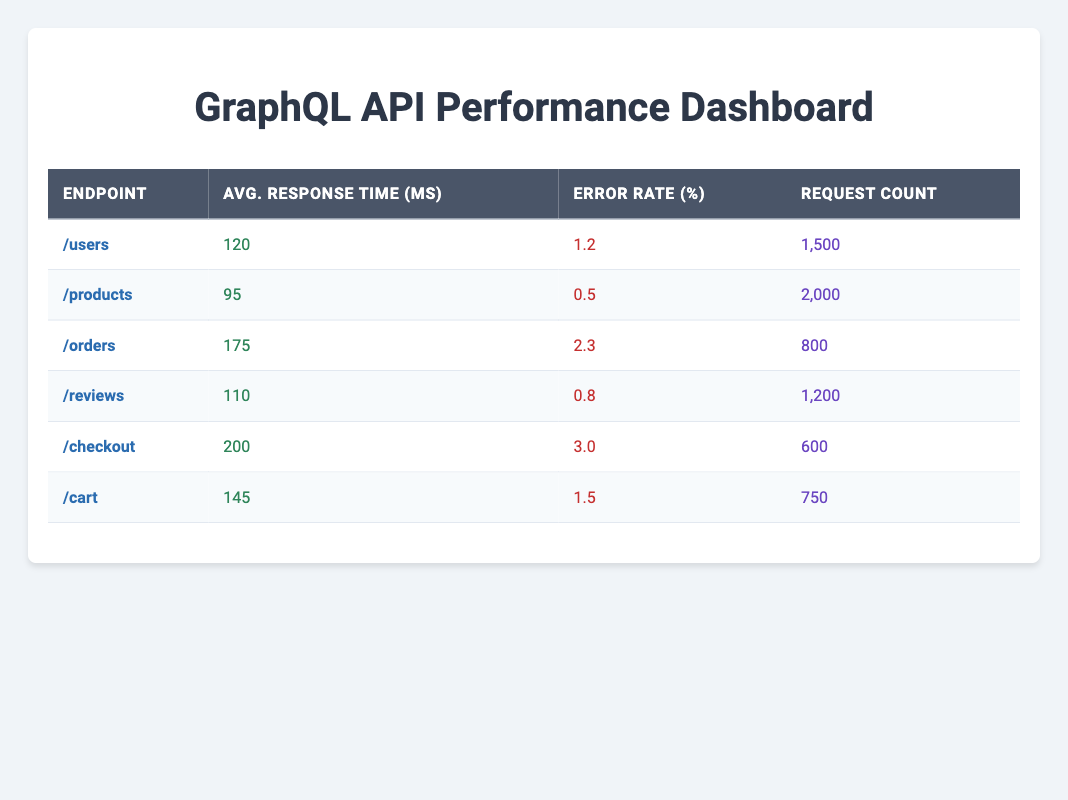What is the average response time for the /products endpoint? The average response time for the /products endpoint is directly provided in the table, which shows the value as 95 milliseconds.
Answer: 95 ms Which endpoint has the highest error rate? To determine which endpoint has the highest error rate, we look through the error rate percentages in the table. The /checkout endpoint has the highest value at 3.0%.
Answer: /checkout Calculate the average response time of all endpoints. First, we sum the average response times: 120 + 95 + 175 + 110 + 200 + 145 = 945 ms. Since there are 6 endpoints, we divide: 945 / 6 = 157.5 ms.
Answer: 157.5 ms Is the error rate for /reviews lower than 1%? In the table, the error rate for /reviews is listed as 0.8%, which is indeed lower than 1%.
Answer: Yes Which endpoint has a request count of 800? The request count for each endpoint is listed in the table. The /orders endpoint has a request count of 800.
Answer: /orders What is the sum of the request counts for endpoints with an error rate below 2%? The endpoints with error rates below 2% are /users (1500), /products (2000), and /reviews (1200). Adding these request counts gives us: 1500 + 2000 + 1200 = 4700.
Answer: 4700 How does the average response time of the /checkout endpoint compare to the /cart endpoint? The average response time for /checkout is 200 ms and for /cart, it is 145 ms. Since 200 ms is greater than 145 ms, we can conclude that the /checkout endpoint has a longer response time than the /cart endpoint.
Answer: /checkout has a longer response time Are there more requests made to the /cart endpoint than the /checkout endpoint? The request count for /cart is 750, while for /checkout it is 600. Since 750 is more than 600, the statement is true.
Answer: Yes What percentage of the total requests were made to the /products endpoint? The total request count is 1500 + 2000 + 800 + 1200 + 600 + 750 = 6050. The request count for /products is 2000. To find the percentage, calculate (2000 / 6050) * 100, which gives approximately 33.06%.
Answer: 33.06% 